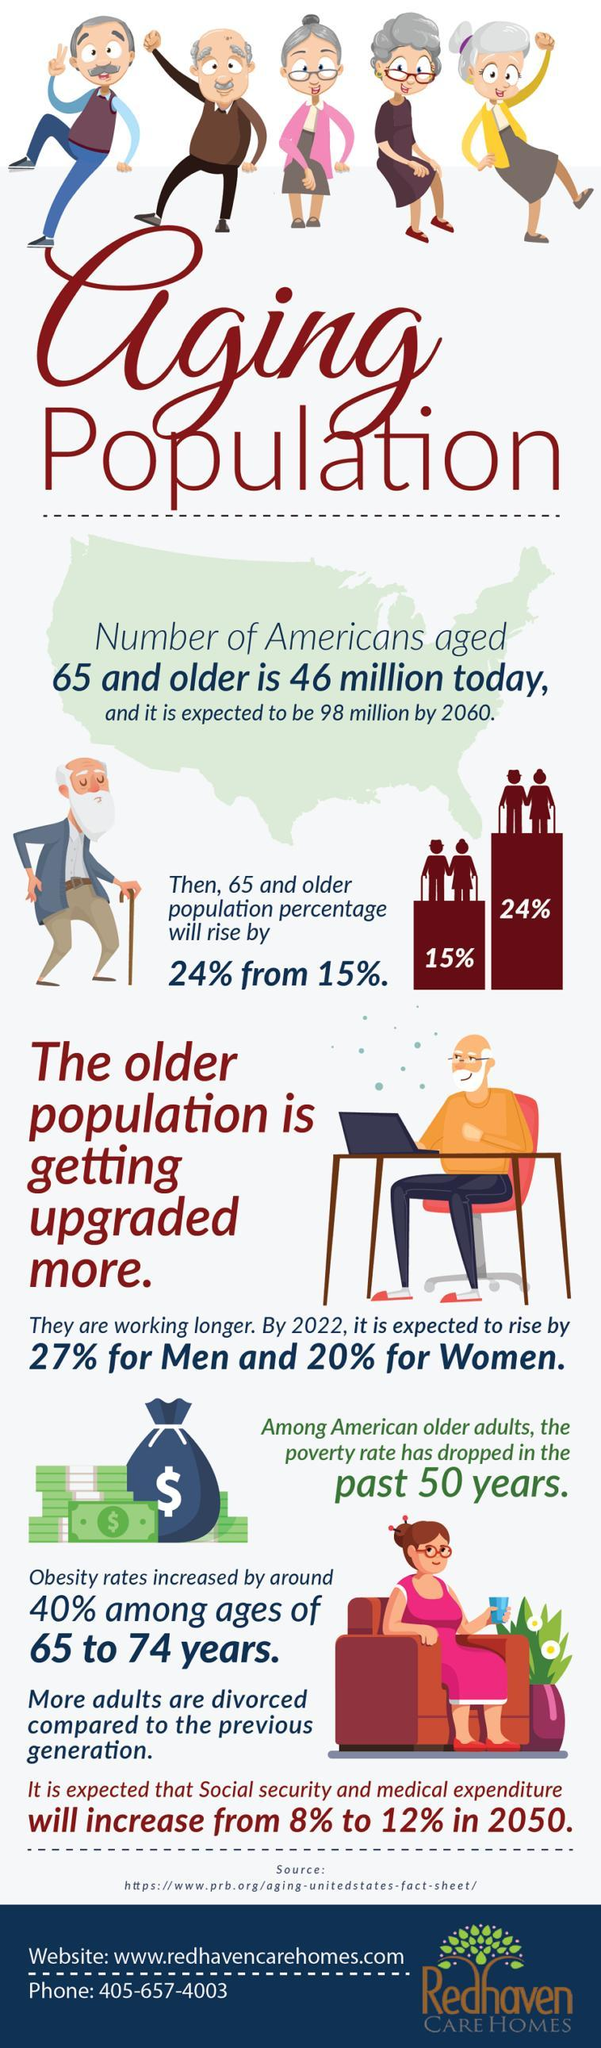What is the percentage increase of the 65 and older population?
Answer the question with a short phrase. 9% What is the percentage increase in social security and medical expenditure in 2050? 4% 